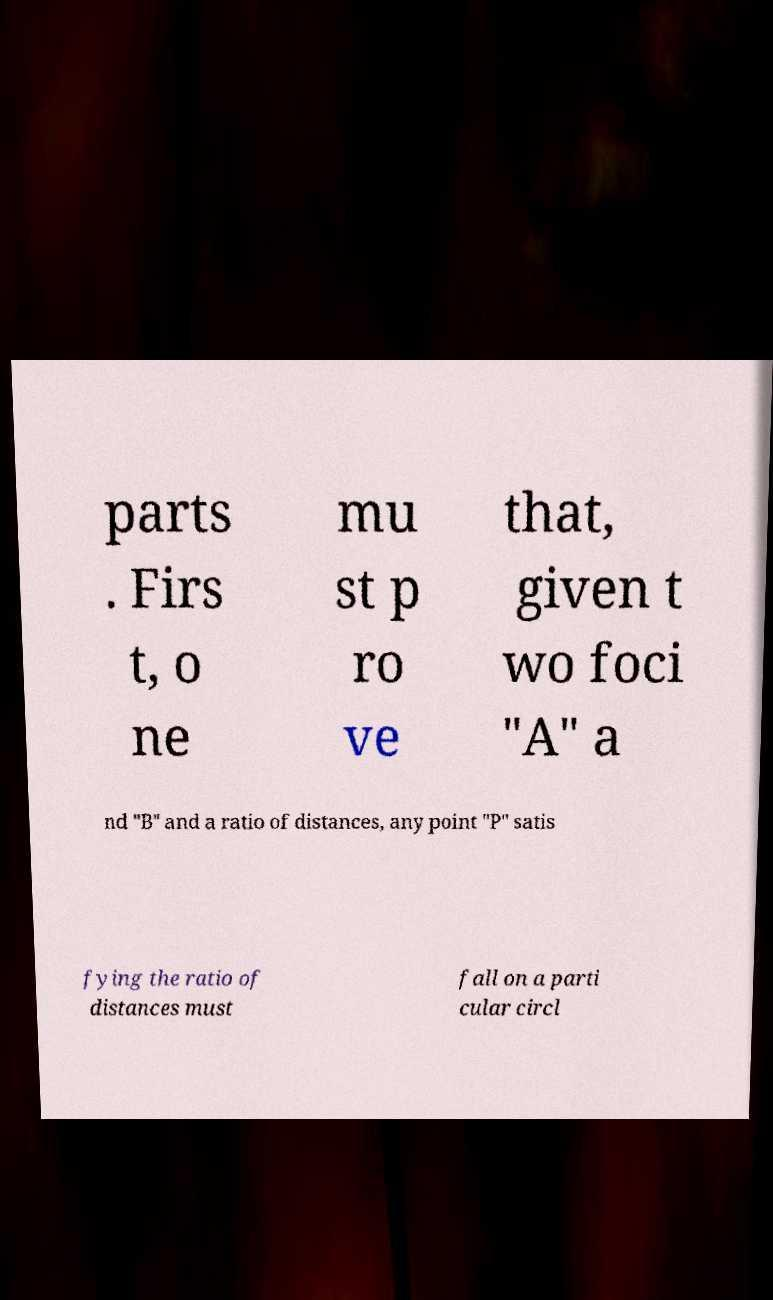What messages or text are displayed in this image? I need them in a readable, typed format. parts . Firs t, o ne mu st p ro ve that, given t wo foci "A" a nd "B" and a ratio of distances, any point "P" satis fying the ratio of distances must fall on a parti cular circl 